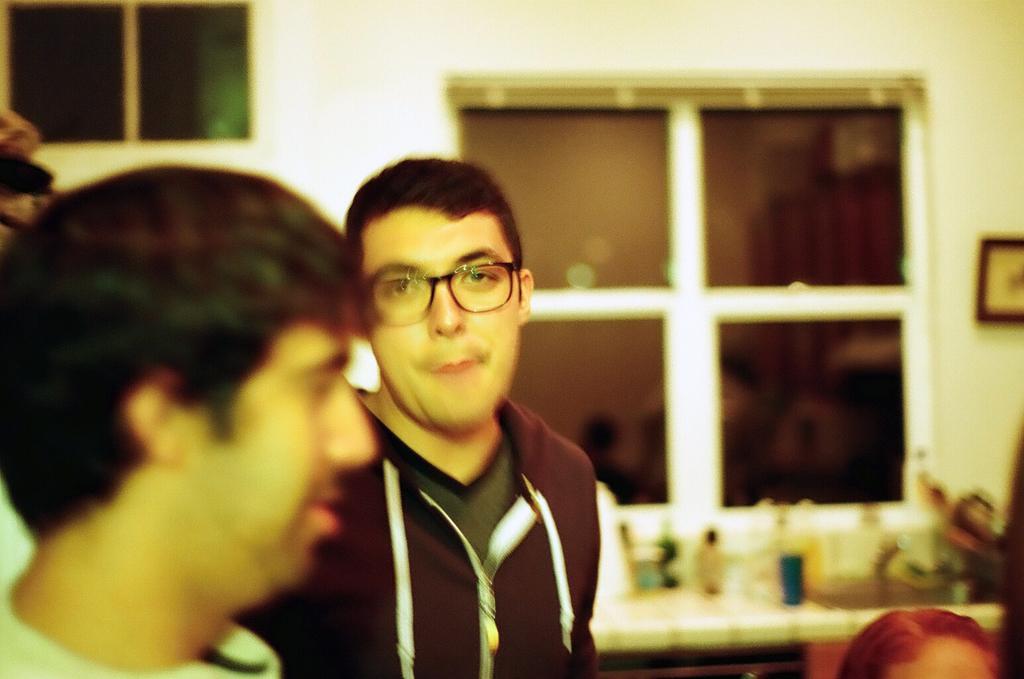Can you describe this image briefly? In this image we can see a few people and also we can see a table, on the table, we can see some objects, in the background, we can see the windows and a photo frame on the wall. 